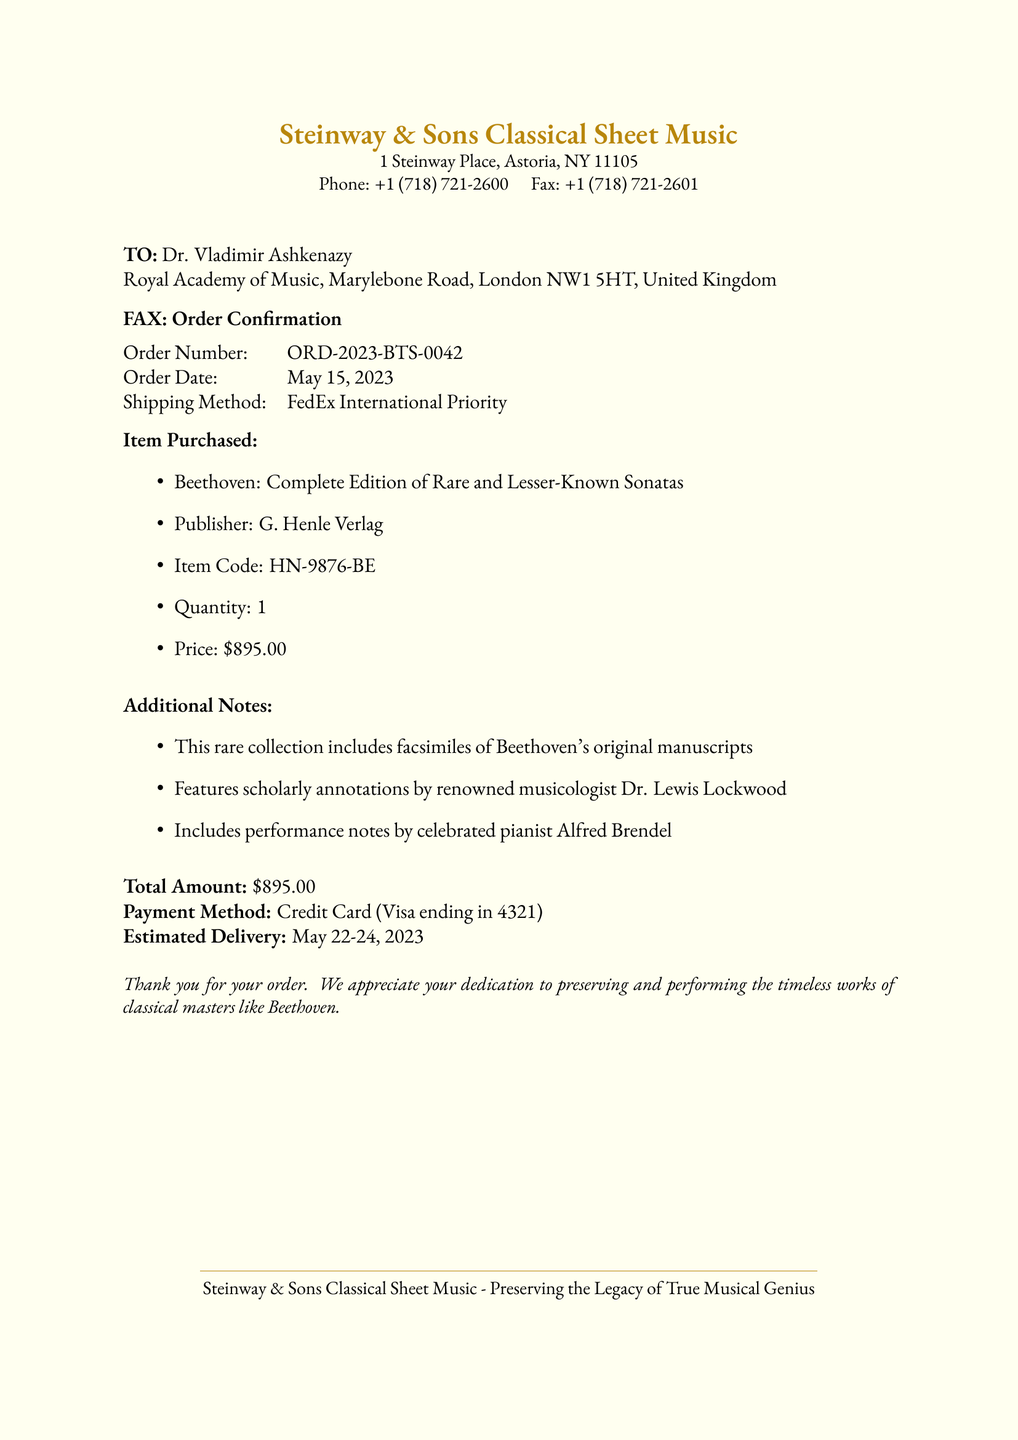What is the order number? The order number is stated in the document under the Order Number section.
Answer: ORD-2023-BTS-0042 Who is the recipient of the fax? The recipient's name and institution are mentioned at the beginning of the document.
Answer: Dr. Vladimir Ashkenazy What is the price of the item purchased? The document specifies the price under the Item Purchased section.
Answer: $895.00 What is the estimated delivery date? The estimated delivery dates are listed towards the end of the document.
Answer: May 22-24, 2023 What publisher produced the sheet music? The publisher's name is found in the Item Purchased section of the document.
Answer: G. Henle Verlag What method of payment was used? The payment method is clearly indicated in the document towards the end.
Answer: Credit Card (Visa ending in 4321) How many copies of the item were ordered? The quantity ordered is mentioned in the Item Purchased section.
Answer: 1 What method was used for shipping? The shipping method is detailed in the document under shipping information.
Answer: FedEx International Priority What additional feature does the collection include? The additional notes section outlines special features of the purchase.
Answer: Facsimiles of Beethoven's original manuscripts 